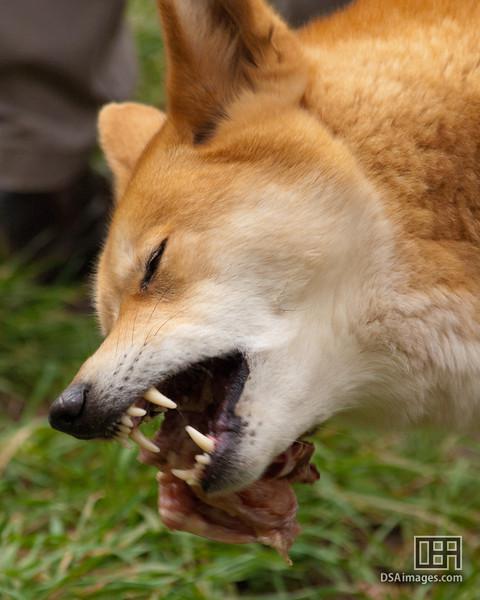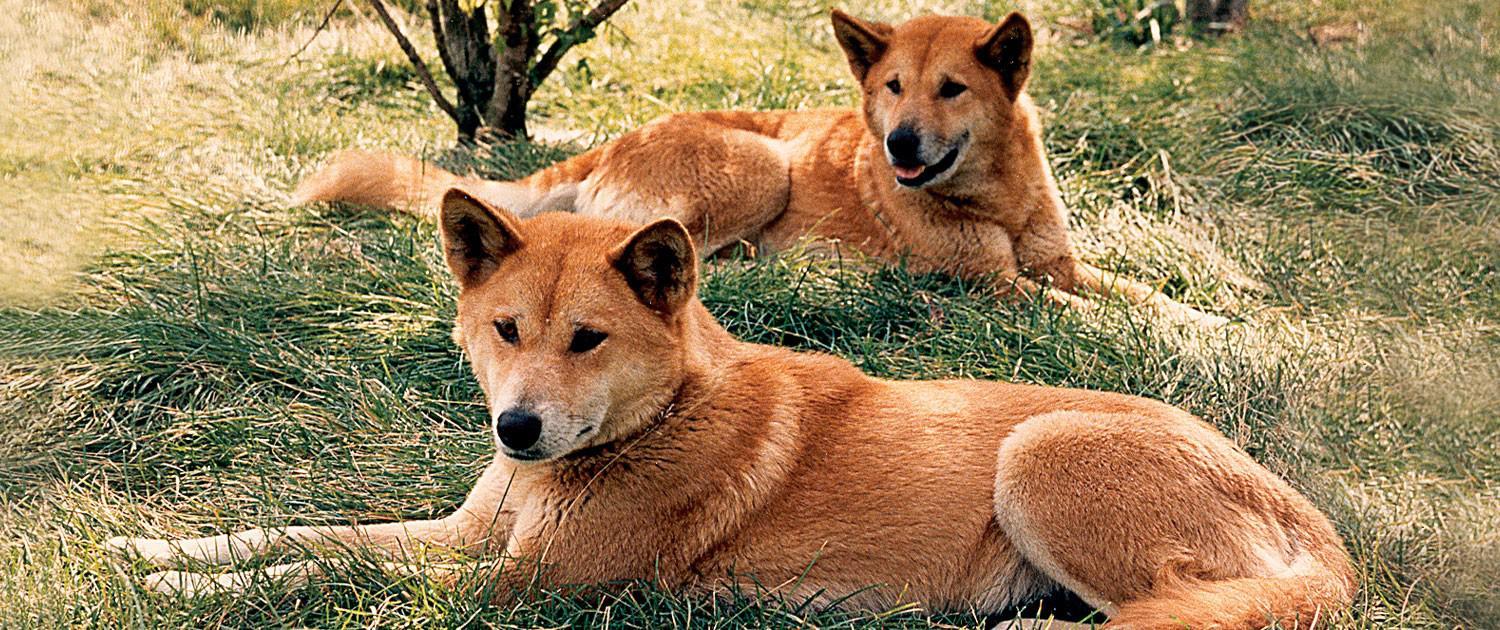The first image is the image on the left, the second image is the image on the right. Analyze the images presented: Is the assertion "The animal in the image on the right is standing on all fours." valid? Answer yes or no. No. The first image is the image on the left, the second image is the image on the right. Evaluate the accuracy of this statement regarding the images: "In the left image, a dog's eyes are narrowed because it looks sleepy.". Is it true? Answer yes or no. No. 